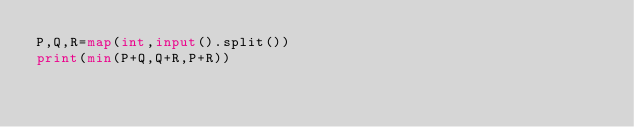<code> <loc_0><loc_0><loc_500><loc_500><_Python_>P,Q,R=map(int,input().split())
print(min(P+Q,Q+R,P+R))</code> 